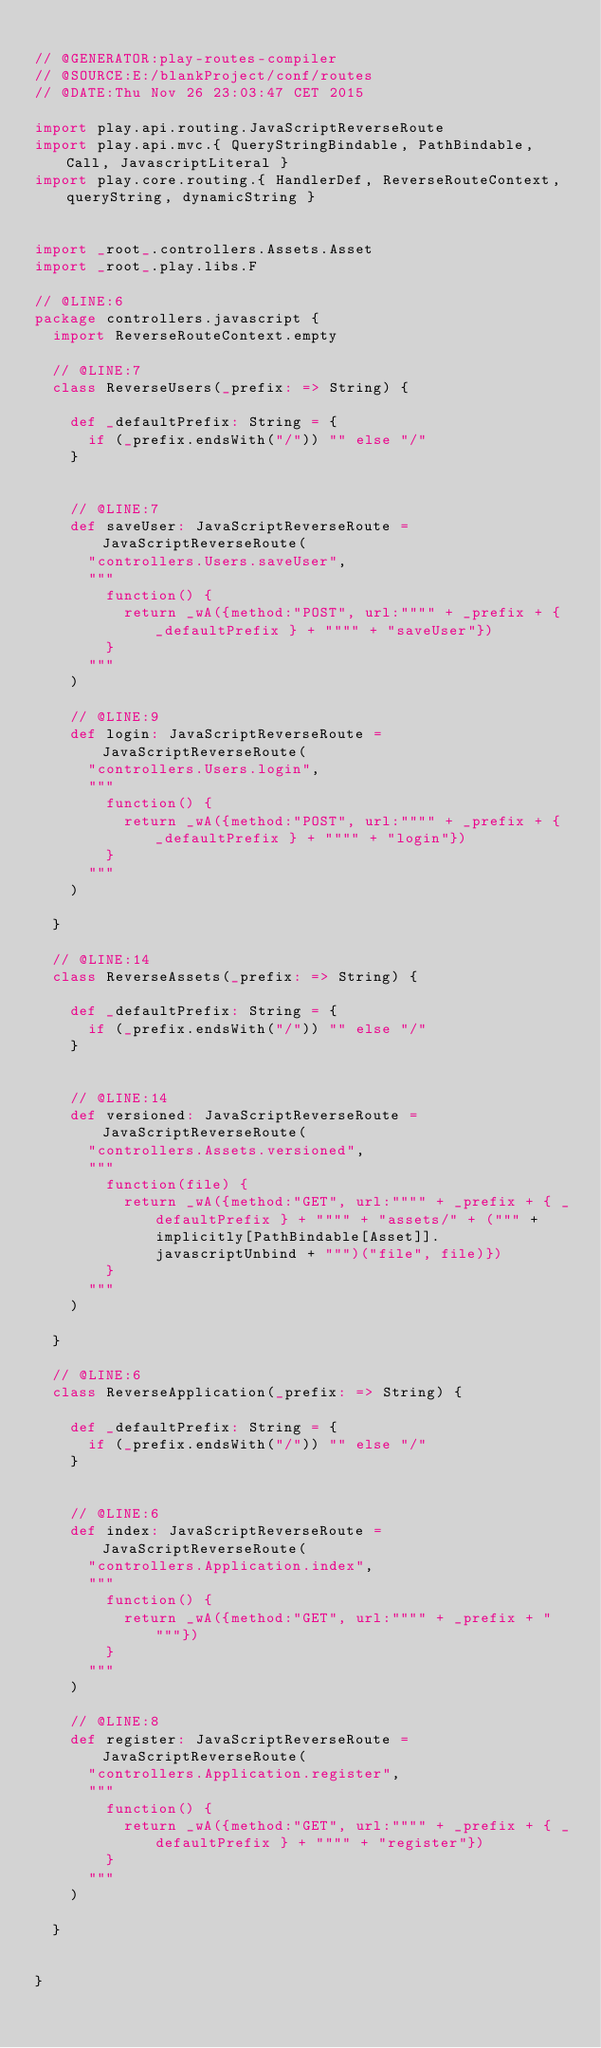<code> <loc_0><loc_0><loc_500><loc_500><_Scala_>
// @GENERATOR:play-routes-compiler
// @SOURCE:E:/blankProject/conf/routes
// @DATE:Thu Nov 26 23:03:47 CET 2015

import play.api.routing.JavaScriptReverseRoute
import play.api.mvc.{ QueryStringBindable, PathBindable, Call, JavascriptLiteral }
import play.core.routing.{ HandlerDef, ReverseRouteContext, queryString, dynamicString }


import _root_.controllers.Assets.Asset
import _root_.play.libs.F

// @LINE:6
package controllers.javascript {
  import ReverseRouteContext.empty

  // @LINE:7
  class ReverseUsers(_prefix: => String) {

    def _defaultPrefix: String = {
      if (_prefix.endsWith("/")) "" else "/"
    }

  
    // @LINE:7
    def saveUser: JavaScriptReverseRoute = JavaScriptReverseRoute(
      "controllers.Users.saveUser",
      """
        function() {
          return _wA({method:"POST", url:"""" + _prefix + { _defaultPrefix } + """" + "saveUser"})
        }
      """
    )
  
    // @LINE:9
    def login: JavaScriptReverseRoute = JavaScriptReverseRoute(
      "controllers.Users.login",
      """
        function() {
          return _wA({method:"POST", url:"""" + _prefix + { _defaultPrefix } + """" + "login"})
        }
      """
    )
  
  }

  // @LINE:14
  class ReverseAssets(_prefix: => String) {

    def _defaultPrefix: String = {
      if (_prefix.endsWith("/")) "" else "/"
    }

  
    // @LINE:14
    def versioned: JavaScriptReverseRoute = JavaScriptReverseRoute(
      "controllers.Assets.versioned",
      """
        function(file) {
          return _wA({method:"GET", url:"""" + _prefix + { _defaultPrefix } + """" + "assets/" + (""" + implicitly[PathBindable[Asset]].javascriptUnbind + """)("file", file)})
        }
      """
    )
  
  }

  // @LINE:6
  class ReverseApplication(_prefix: => String) {

    def _defaultPrefix: String = {
      if (_prefix.endsWith("/")) "" else "/"
    }

  
    // @LINE:6
    def index: JavaScriptReverseRoute = JavaScriptReverseRoute(
      "controllers.Application.index",
      """
        function() {
          return _wA({method:"GET", url:"""" + _prefix + """"})
        }
      """
    )
  
    // @LINE:8
    def register: JavaScriptReverseRoute = JavaScriptReverseRoute(
      "controllers.Application.register",
      """
        function() {
          return _wA({method:"GET", url:"""" + _prefix + { _defaultPrefix } + """" + "register"})
        }
      """
    )
  
  }


}</code> 